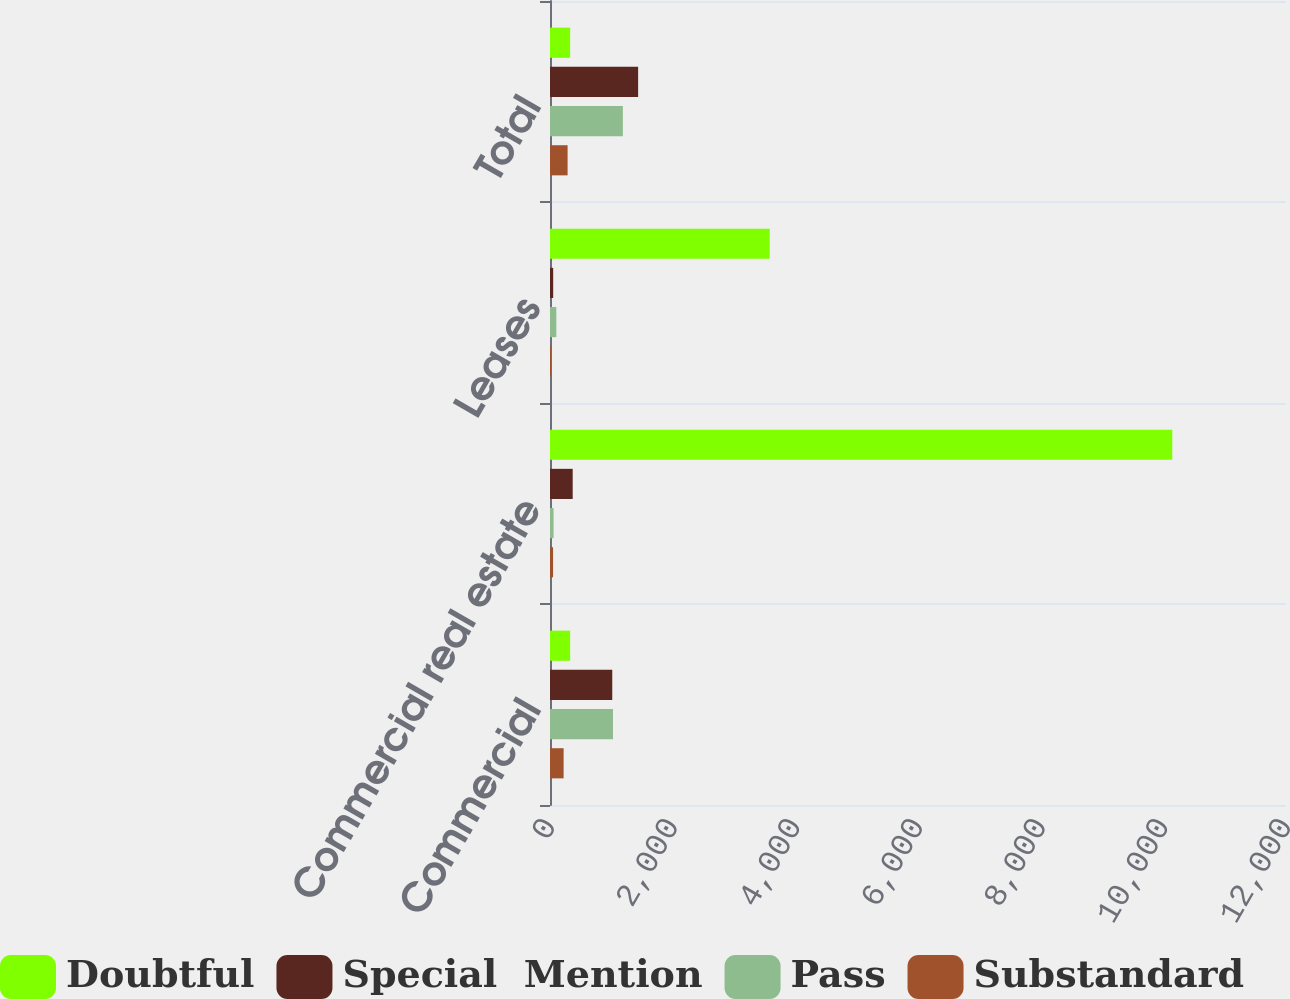Convert chart to OTSL. <chart><loc_0><loc_0><loc_500><loc_500><stacked_bar_chart><ecel><fcel>Commercial<fcel>Commercial real estate<fcel>Leases<fcel>Total<nl><fcel>Doubtful<fcel>328.5<fcel>10146<fcel>3583<fcel>328.5<nl><fcel>Special  Mention<fcel>1015<fcel>370<fcel>52<fcel>1437<nl><fcel>Pass<fcel>1027<fcel>58<fcel>103<fcel>1188<nl><fcel>Substandard<fcel>222<fcel>50<fcel>15<fcel>287<nl></chart> 